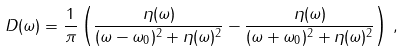Convert formula to latex. <formula><loc_0><loc_0><loc_500><loc_500>D ( \omega ) = \frac { 1 } { \pi } \left ( \frac { \eta ( \omega ) } { ( \omega - \omega _ { 0 } ) ^ { 2 } + \eta ( \omega ) ^ { 2 } } - \frac { \eta ( \omega ) } { ( \omega + \omega _ { 0 } ) ^ { 2 } + \eta ( \omega ) ^ { 2 } } \right ) \, ,</formula> 